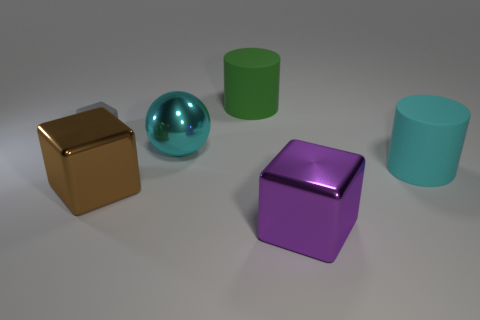Add 3 brown metallic cubes. How many objects exist? 9 Subtract all spheres. How many objects are left? 5 Add 4 green matte cylinders. How many green matte cylinders are left? 5 Add 2 small purple metallic balls. How many small purple metallic balls exist? 2 Subtract 0 green cubes. How many objects are left? 6 Subtract all large cyan matte cubes. Subtract all green matte cylinders. How many objects are left? 5 